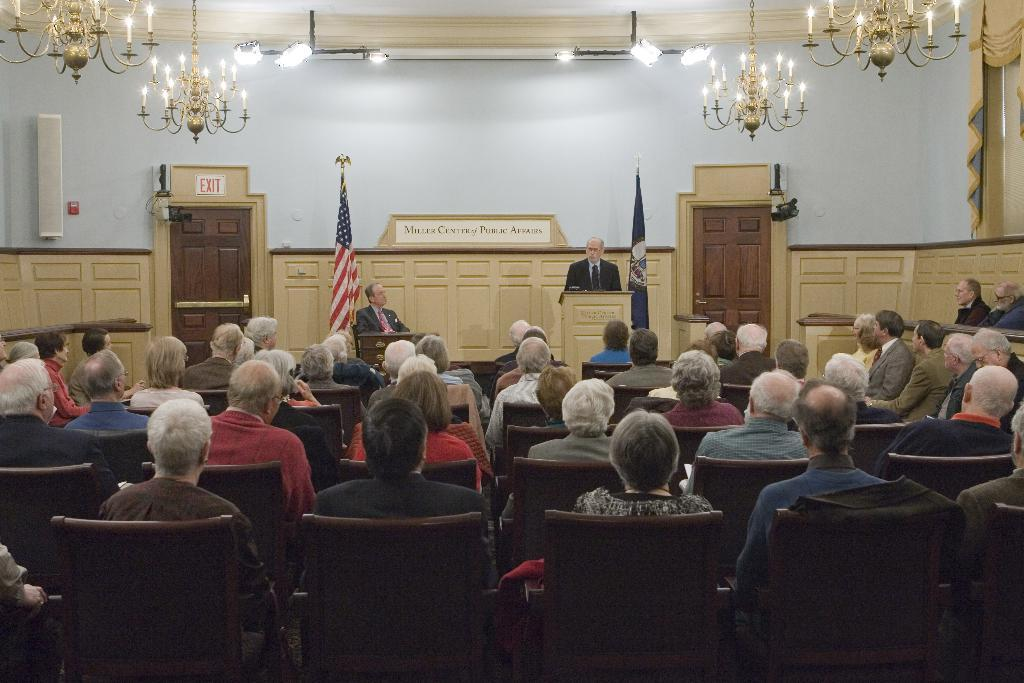What are the people in the image doing? There is a group of people sitting in chairs, which suggests they might be attending an event or meeting. Who is the person standing in front of the podium? The person standing in front of the podium might be a speaker or presenter. What can be seen in the background of the image? There is a flag, a wooden door, and an exit board visible in the background. What is the source of light in the image? There is a light on the top, which could be a ceiling light or a spotlight. What type of coast can be seen in the image? There is no coast present in the image; it features a group of people sitting in chairs, a person standing at a podium, and various background elements. Is there a bomb visible in the image? No, there is no bomb present in the image. 